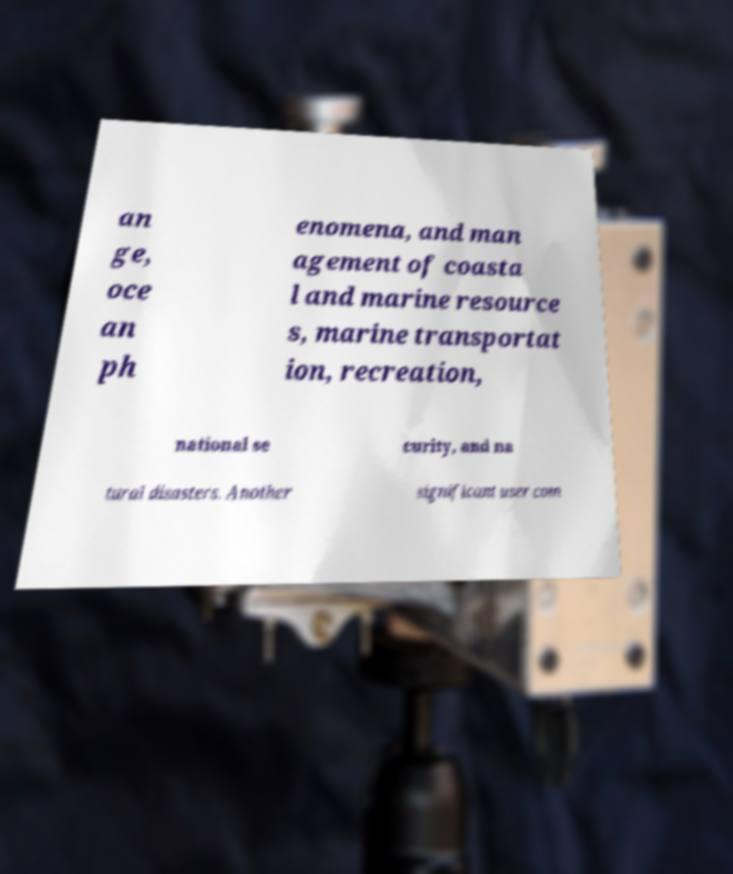Please read and relay the text visible in this image. What does it say? an ge, oce an ph enomena, and man agement of coasta l and marine resource s, marine transportat ion, recreation, national se curity, and na tural disasters. Another significant user com 